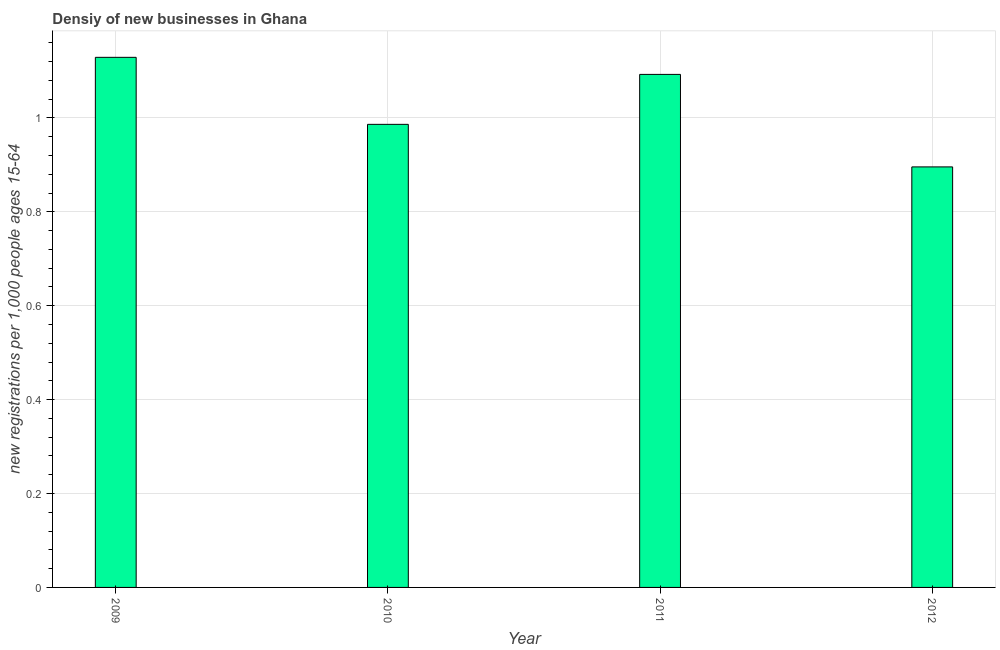Does the graph contain grids?
Offer a terse response. Yes. What is the title of the graph?
Give a very brief answer. Densiy of new businesses in Ghana. What is the label or title of the Y-axis?
Keep it short and to the point. New registrations per 1,0 people ages 15-64. What is the density of new business in 2010?
Provide a succinct answer. 0.99. Across all years, what is the maximum density of new business?
Ensure brevity in your answer.  1.13. Across all years, what is the minimum density of new business?
Make the answer very short. 0.9. In which year was the density of new business maximum?
Give a very brief answer. 2009. In which year was the density of new business minimum?
Offer a very short reply. 2012. What is the sum of the density of new business?
Your response must be concise. 4.1. What is the difference between the density of new business in 2009 and 2011?
Provide a short and direct response. 0.04. What is the median density of new business?
Your response must be concise. 1.04. Do a majority of the years between 2009 and 2011 (inclusive) have density of new business greater than 0.04 ?
Give a very brief answer. Yes. What is the ratio of the density of new business in 2010 to that in 2011?
Provide a short and direct response. 0.9. What is the difference between the highest and the second highest density of new business?
Provide a short and direct response. 0.04. Is the sum of the density of new business in 2009 and 2010 greater than the maximum density of new business across all years?
Ensure brevity in your answer.  Yes. What is the difference between the highest and the lowest density of new business?
Give a very brief answer. 0.23. In how many years, is the density of new business greater than the average density of new business taken over all years?
Offer a terse response. 2. How many bars are there?
Offer a terse response. 4. Are all the bars in the graph horizontal?
Make the answer very short. No. How many years are there in the graph?
Give a very brief answer. 4. What is the new registrations per 1,000 people ages 15-64 in 2009?
Keep it short and to the point. 1.13. What is the new registrations per 1,000 people ages 15-64 of 2010?
Give a very brief answer. 0.99. What is the new registrations per 1,000 people ages 15-64 in 2011?
Your answer should be compact. 1.09. What is the new registrations per 1,000 people ages 15-64 of 2012?
Give a very brief answer. 0.9. What is the difference between the new registrations per 1,000 people ages 15-64 in 2009 and 2010?
Offer a very short reply. 0.14. What is the difference between the new registrations per 1,000 people ages 15-64 in 2009 and 2011?
Offer a terse response. 0.04. What is the difference between the new registrations per 1,000 people ages 15-64 in 2009 and 2012?
Your answer should be very brief. 0.23. What is the difference between the new registrations per 1,000 people ages 15-64 in 2010 and 2011?
Offer a very short reply. -0.11. What is the difference between the new registrations per 1,000 people ages 15-64 in 2010 and 2012?
Make the answer very short. 0.09. What is the difference between the new registrations per 1,000 people ages 15-64 in 2011 and 2012?
Ensure brevity in your answer.  0.2. What is the ratio of the new registrations per 1,000 people ages 15-64 in 2009 to that in 2010?
Offer a terse response. 1.15. What is the ratio of the new registrations per 1,000 people ages 15-64 in 2009 to that in 2011?
Keep it short and to the point. 1.03. What is the ratio of the new registrations per 1,000 people ages 15-64 in 2009 to that in 2012?
Your answer should be compact. 1.26. What is the ratio of the new registrations per 1,000 people ages 15-64 in 2010 to that in 2011?
Offer a terse response. 0.9. What is the ratio of the new registrations per 1,000 people ages 15-64 in 2010 to that in 2012?
Provide a succinct answer. 1.1. What is the ratio of the new registrations per 1,000 people ages 15-64 in 2011 to that in 2012?
Offer a terse response. 1.22. 